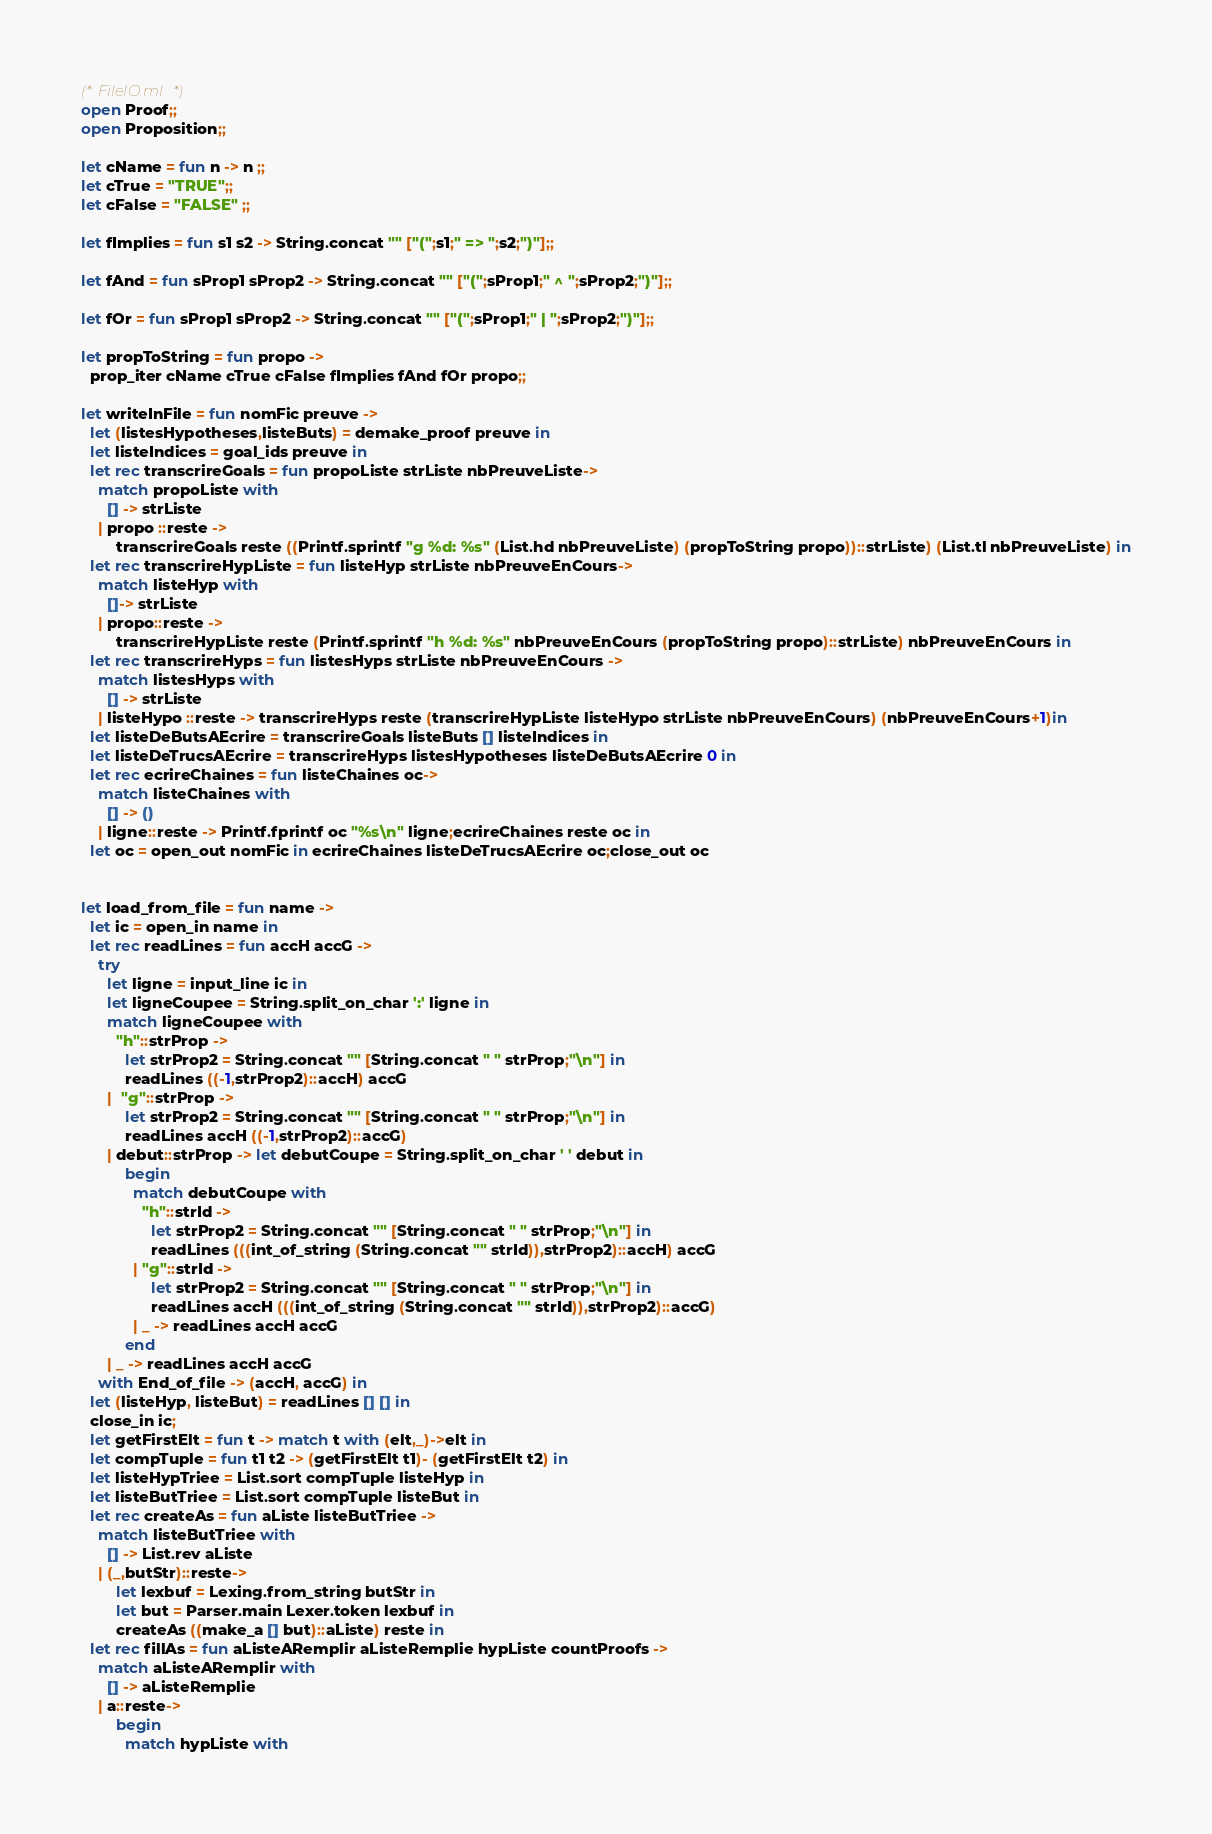<code> <loc_0><loc_0><loc_500><loc_500><_OCaml_>(* FileIO.ml *)
open Proof;;
open Proposition;;

let cName = fun n -> n ;;
let cTrue = "TRUE";;
let cFalse = "FALSE" ;;

let fImplies = fun s1 s2 -> String.concat "" ["(";s1;" => ";s2;")"];;

let fAnd = fun sProp1 sProp2 -> String.concat "" ["(";sProp1;" ^ ";sProp2;")"];;

let fOr = fun sProp1 sProp2 -> String.concat "" ["(";sProp1;" | ";sProp2;")"];;

let propToString = fun propo ->
  prop_iter cName cTrue cFalse fImplies fAnd fOr propo;;

let writeInFile = fun nomFic preuve ->
  let (listesHypotheses,listeButs) = demake_proof preuve in
  let listeIndices = goal_ids preuve in
  let rec transcrireGoals = fun propoListe strListe nbPreuveListe->
    match propoListe with
      [] -> strListe
    | propo ::reste -> 
        transcrireGoals reste ((Printf.sprintf "g %d: %s" (List.hd nbPreuveListe) (propToString propo))::strListe) (List.tl nbPreuveListe) in
  let rec transcrireHypListe = fun listeHyp strListe nbPreuveEnCours->
    match listeHyp with
      []-> strListe
    | propo::reste -> 
        transcrireHypListe reste (Printf.sprintf "h %d: %s" nbPreuveEnCours (propToString propo)::strListe) nbPreuveEnCours in
  let rec transcrireHyps = fun listesHyps strListe nbPreuveEnCours ->
    match listesHyps with
      [] -> strListe
    | listeHypo ::reste -> transcrireHyps reste (transcrireHypListe listeHypo strListe nbPreuveEnCours) (nbPreuveEnCours+1)in
  let listeDeButsAEcrire = transcrireGoals listeButs [] listeIndices in
  let listeDeTrucsAEcrire = transcrireHyps listesHypotheses listeDeButsAEcrire 0 in
  let rec ecrireChaines = fun listeChaines oc->
    match listeChaines with
      [] -> ()
    | ligne::reste -> Printf.fprintf oc "%s\n" ligne;ecrireChaines reste oc in
  let oc = open_out nomFic in ecrireChaines listeDeTrucsAEcrire oc;close_out oc


let load_from_file = fun name ->
  let ic = open_in name in
  let rec readLines = fun accH accG ->
    try
      let ligne = input_line ic in
      let ligneCoupee = String.split_on_char ':' ligne in
      match ligneCoupee with
        "h"::strProp -> 
          let strProp2 = String.concat "" [String.concat " " strProp;"\n"] in
          readLines ((-1,strProp2)::accH) accG
      |  "g"::strProp -> 
          let strProp2 = String.concat "" [String.concat " " strProp;"\n"] in
          readLines accH ((-1,strProp2)::accG)
      | debut::strProp -> let debutCoupe = String.split_on_char ' ' debut in
          begin
            match debutCoupe with
              "h"::strId ->
                let strProp2 = String.concat "" [String.concat " " strProp;"\n"] in
                readLines (((int_of_string (String.concat "" strId)),strProp2)::accH) accG
            | "g"::strId ->
                let strProp2 = String.concat "" [String.concat " " strProp;"\n"] in
                readLines accH (((int_of_string (String.concat "" strId)),strProp2)::accG)
            | _ -> readLines accH accG
          end
      | _ -> readLines accH accG
    with End_of_file -> (accH, accG) in
  let (listeHyp, listeBut) = readLines [] [] in
  close_in ic;
  let getFirstElt = fun t -> match t with (elt,_)->elt in
  let compTuple = fun t1 t2 -> (getFirstElt t1)- (getFirstElt t2) in
  let listeHypTriee = List.sort compTuple listeHyp in
  let listeButTriee = List.sort compTuple listeBut in
  let rec createAs = fun aListe listeButTriee ->
    match listeButTriee with
      [] -> List.rev aListe
    | (_,butStr)::reste-> 
        let lexbuf = Lexing.from_string butStr in
        let but = Parser.main Lexer.token lexbuf in
        createAs ((make_a [] but)::aListe) reste in
  let rec fillAs = fun aListeARemplir aListeRemplie hypListe countProofs ->
    match aListeARemplir with
      [] -> aListeRemplie
    | a::reste-> 
        begin
          match hypListe with</code> 